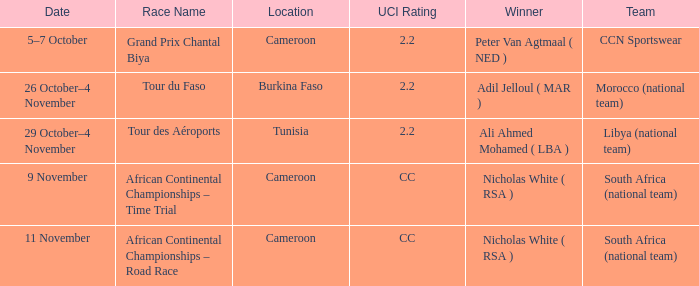What is the location of the race on 11 November? Cameroon. 